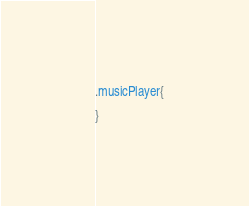Convert code to text. <code><loc_0><loc_0><loc_500><loc_500><_CSS_>.musicPlayer{

}</code> 